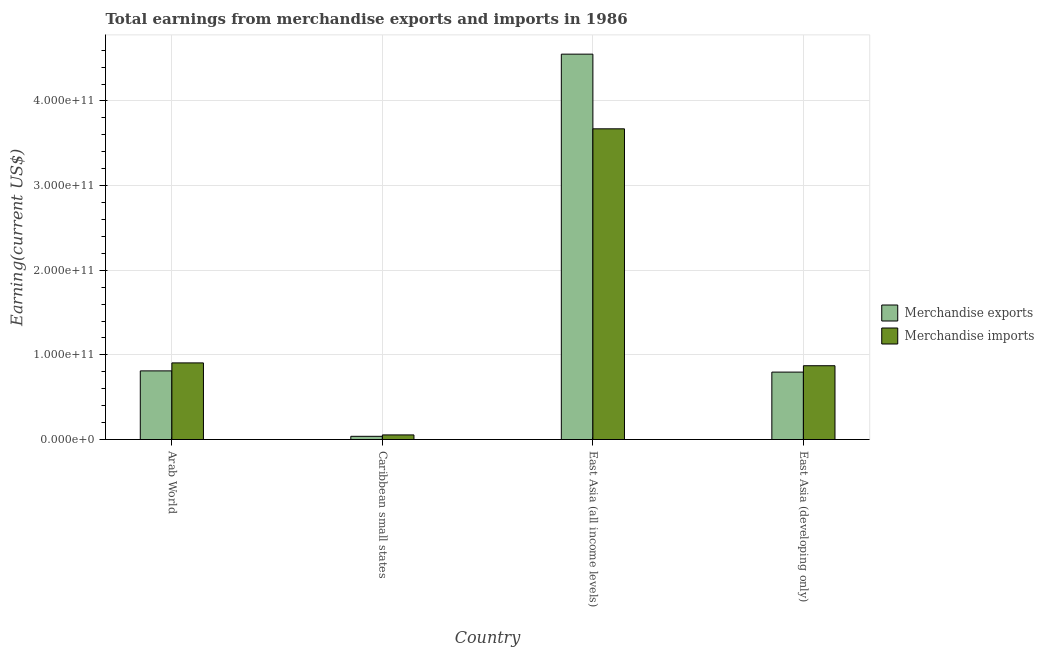Are the number of bars per tick equal to the number of legend labels?
Make the answer very short. Yes. What is the label of the 4th group of bars from the left?
Ensure brevity in your answer.  East Asia (developing only). What is the earnings from merchandise imports in Caribbean small states?
Provide a short and direct response. 5.44e+09. Across all countries, what is the maximum earnings from merchandise exports?
Ensure brevity in your answer.  4.55e+11. Across all countries, what is the minimum earnings from merchandise imports?
Offer a terse response. 5.44e+09. In which country was the earnings from merchandise imports maximum?
Ensure brevity in your answer.  East Asia (all income levels). In which country was the earnings from merchandise exports minimum?
Ensure brevity in your answer.  Caribbean small states. What is the total earnings from merchandise imports in the graph?
Provide a short and direct response. 5.50e+11. What is the difference between the earnings from merchandise exports in Arab World and that in Caribbean small states?
Keep it short and to the point. 7.73e+1. What is the difference between the earnings from merchandise exports in East Asia (all income levels) and the earnings from merchandise imports in Caribbean small states?
Keep it short and to the point. 4.50e+11. What is the average earnings from merchandise imports per country?
Your answer should be very brief. 1.38e+11. What is the difference between the earnings from merchandise imports and earnings from merchandise exports in East Asia (developing only)?
Offer a terse response. 7.54e+09. In how many countries, is the earnings from merchandise imports greater than 420000000000 US$?
Your response must be concise. 0. What is the ratio of the earnings from merchandise exports in Arab World to that in East Asia (developing only)?
Offer a terse response. 1.02. Is the difference between the earnings from merchandise imports in Arab World and East Asia (developing only) greater than the difference between the earnings from merchandise exports in Arab World and East Asia (developing only)?
Your answer should be compact. Yes. What is the difference between the highest and the second highest earnings from merchandise imports?
Keep it short and to the point. 2.77e+11. What is the difference between the highest and the lowest earnings from merchandise exports?
Ensure brevity in your answer.  4.51e+11. What does the 1st bar from the left in East Asia (all income levels) represents?
Offer a terse response. Merchandise exports. What does the 1st bar from the right in East Asia (developing only) represents?
Your answer should be compact. Merchandise imports. How many bars are there?
Your response must be concise. 8. Are all the bars in the graph horizontal?
Keep it short and to the point. No. What is the difference between two consecutive major ticks on the Y-axis?
Your answer should be very brief. 1.00e+11. How many legend labels are there?
Provide a succinct answer. 2. How are the legend labels stacked?
Make the answer very short. Vertical. What is the title of the graph?
Provide a succinct answer. Total earnings from merchandise exports and imports in 1986. What is the label or title of the Y-axis?
Offer a very short reply. Earning(current US$). What is the Earning(current US$) in Merchandise exports in Arab World?
Provide a succinct answer. 8.11e+1. What is the Earning(current US$) of Merchandise imports in Arab World?
Your response must be concise. 9.05e+1. What is the Earning(current US$) of Merchandise exports in Caribbean small states?
Your answer should be very brief. 3.78e+09. What is the Earning(current US$) in Merchandise imports in Caribbean small states?
Your answer should be compact. 5.44e+09. What is the Earning(current US$) in Merchandise exports in East Asia (all income levels)?
Ensure brevity in your answer.  4.55e+11. What is the Earning(current US$) in Merchandise imports in East Asia (all income levels)?
Keep it short and to the point. 3.67e+11. What is the Earning(current US$) in Merchandise exports in East Asia (developing only)?
Offer a very short reply. 7.96e+1. What is the Earning(current US$) of Merchandise imports in East Asia (developing only)?
Your answer should be compact. 8.72e+1. Across all countries, what is the maximum Earning(current US$) of Merchandise exports?
Your answer should be compact. 4.55e+11. Across all countries, what is the maximum Earning(current US$) in Merchandise imports?
Your response must be concise. 3.67e+11. Across all countries, what is the minimum Earning(current US$) in Merchandise exports?
Ensure brevity in your answer.  3.78e+09. Across all countries, what is the minimum Earning(current US$) in Merchandise imports?
Ensure brevity in your answer.  5.44e+09. What is the total Earning(current US$) of Merchandise exports in the graph?
Ensure brevity in your answer.  6.20e+11. What is the total Earning(current US$) in Merchandise imports in the graph?
Provide a succinct answer. 5.50e+11. What is the difference between the Earning(current US$) in Merchandise exports in Arab World and that in Caribbean small states?
Give a very brief answer. 7.73e+1. What is the difference between the Earning(current US$) of Merchandise imports in Arab World and that in Caribbean small states?
Your answer should be compact. 8.51e+1. What is the difference between the Earning(current US$) of Merchandise exports in Arab World and that in East Asia (all income levels)?
Provide a succinct answer. -3.74e+11. What is the difference between the Earning(current US$) in Merchandise imports in Arab World and that in East Asia (all income levels)?
Keep it short and to the point. -2.77e+11. What is the difference between the Earning(current US$) in Merchandise exports in Arab World and that in East Asia (developing only)?
Provide a succinct answer. 1.44e+09. What is the difference between the Earning(current US$) of Merchandise imports in Arab World and that in East Asia (developing only)?
Provide a succinct answer. 3.33e+09. What is the difference between the Earning(current US$) in Merchandise exports in Caribbean small states and that in East Asia (all income levels)?
Your response must be concise. -4.51e+11. What is the difference between the Earning(current US$) in Merchandise imports in Caribbean small states and that in East Asia (all income levels)?
Offer a very short reply. -3.62e+11. What is the difference between the Earning(current US$) of Merchandise exports in Caribbean small states and that in East Asia (developing only)?
Keep it short and to the point. -7.59e+1. What is the difference between the Earning(current US$) of Merchandise imports in Caribbean small states and that in East Asia (developing only)?
Give a very brief answer. -8.17e+1. What is the difference between the Earning(current US$) of Merchandise exports in East Asia (all income levels) and that in East Asia (developing only)?
Your response must be concise. 3.76e+11. What is the difference between the Earning(current US$) in Merchandise imports in East Asia (all income levels) and that in East Asia (developing only)?
Provide a short and direct response. 2.80e+11. What is the difference between the Earning(current US$) of Merchandise exports in Arab World and the Earning(current US$) of Merchandise imports in Caribbean small states?
Your response must be concise. 7.56e+1. What is the difference between the Earning(current US$) in Merchandise exports in Arab World and the Earning(current US$) in Merchandise imports in East Asia (all income levels)?
Your response must be concise. -2.86e+11. What is the difference between the Earning(current US$) of Merchandise exports in Arab World and the Earning(current US$) of Merchandise imports in East Asia (developing only)?
Your response must be concise. -6.10e+09. What is the difference between the Earning(current US$) in Merchandise exports in Caribbean small states and the Earning(current US$) in Merchandise imports in East Asia (all income levels)?
Offer a very short reply. -3.63e+11. What is the difference between the Earning(current US$) in Merchandise exports in Caribbean small states and the Earning(current US$) in Merchandise imports in East Asia (developing only)?
Ensure brevity in your answer.  -8.34e+1. What is the difference between the Earning(current US$) of Merchandise exports in East Asia (all income levels) and the Earning(current US$) of Merchandise imports in East Asia (developing only)?
Your answer should be compact. 3.68e+11. What is the average Earning(current US$) of Merchandise exports per country?
Offer a very short reply. 1.55e+11. What is the average Earning(current US$) in Merchandise imports per country?
Keep it short and to the point. 1.38e+11. What is the difference between the Earning(current US$) of Merchandise exports and Earning(current US$) of Merchandise imports in Arab World?
Offer a terse response. -9.43e+09. What is the difference between the Earning(current US$) in Merchandise exports and Earning(current US$) in Merchandise imports in Caribbean small states?
Provide a short and direct response. -1.66e+09. What is the difference between the Earning(current US$) of Merchandise exports and Earning(current US$) of Merchandise imports in East Asia (all income levels)?
Make the answer very short. 8.82e+1. What is the difference between the Earning(current US$) in Merchandise exports and Earning(current US$) in Merchandise imports in East Asia (developing only)?
Provide a succinct answer. -7.54e+09. What is the ratio of the Earning(current US$) of Merchandise exports in Arab World to that in Caribbean small states?
Your answer should be very brief. 21.42. What is the ratio of the Earning(current US$) of Merchandise imports in Arab World to that in Caribbean small states?
Give a very brief answer. 16.63. What is the ratio of the Earning(current US$) in Merchandise exports in Arab World to that in East Asia (all income levels)?
Your response must be concise. 0.18. What is the ratio of the Earning(current US$) of Merchandise imports in Arab World to that in East Asia (all income levels)?
Give a very brief answer. 0.25. What is the ratio of the Earning(current US$) in Merchandise exports in Arab World to that in East Asia (developing only)?
Give a very brief answer. 1.02. What is the ratio of the Earning(current US$) in Merchandise imports in Arab World to that in East Asia (developing only)?
Ensure brevity in your answer.  1.04. What is the ratio of the Earning(current US$) in Merchandise exports in Caribbean small states to that in East Asia (all income levels)?
Provide a succinct answer. 0.01. What is the ratio of the Earning(current US$) in Merchandise imports in Caribbean small states to that in East Asia (all income levels)?
Offer a very short reply. 0.01. What is the ratio of the Earning(current US$) of Merchandise exports in Caribbean small states to that in East Asia (developing only)?
Your answer should be very brief. 0.05. What is the ratio of the Earning(current US$) in Merchandise imports in Caribbean small states to that in East Asia (developing only)?
Make the answer very short. 0.06. What is the ratio of the Earning(current US$) of Merchandise exports in East Asia (all income levels) to that in East Asia (developing only)?
Give a very brief answer. 5.72. What is the ratio of the Earning(current US$) of Merchandise imports in East Asia (all income levels) to that in East Asia (developing only)?
Provide a short and direct response. 4.21. What is the difference between the highest and the second highest Earning(current US$) of Merchandise exports?
Offer a terse response. 3.74e+11. What is the difference between the highest and the second highest Earning(current US$) of Merchandise imports?
Give a very brief answer. 2.77e+11. What is the difference between the highest and the lowest Earning(current US$) in Merchandise exports?
Your response must be concise. 4.51e+11. What is the difference between the highest and the lowest Earning(current US$) of Merchandise imports?
Your response must be concise. 3.62e+11. 